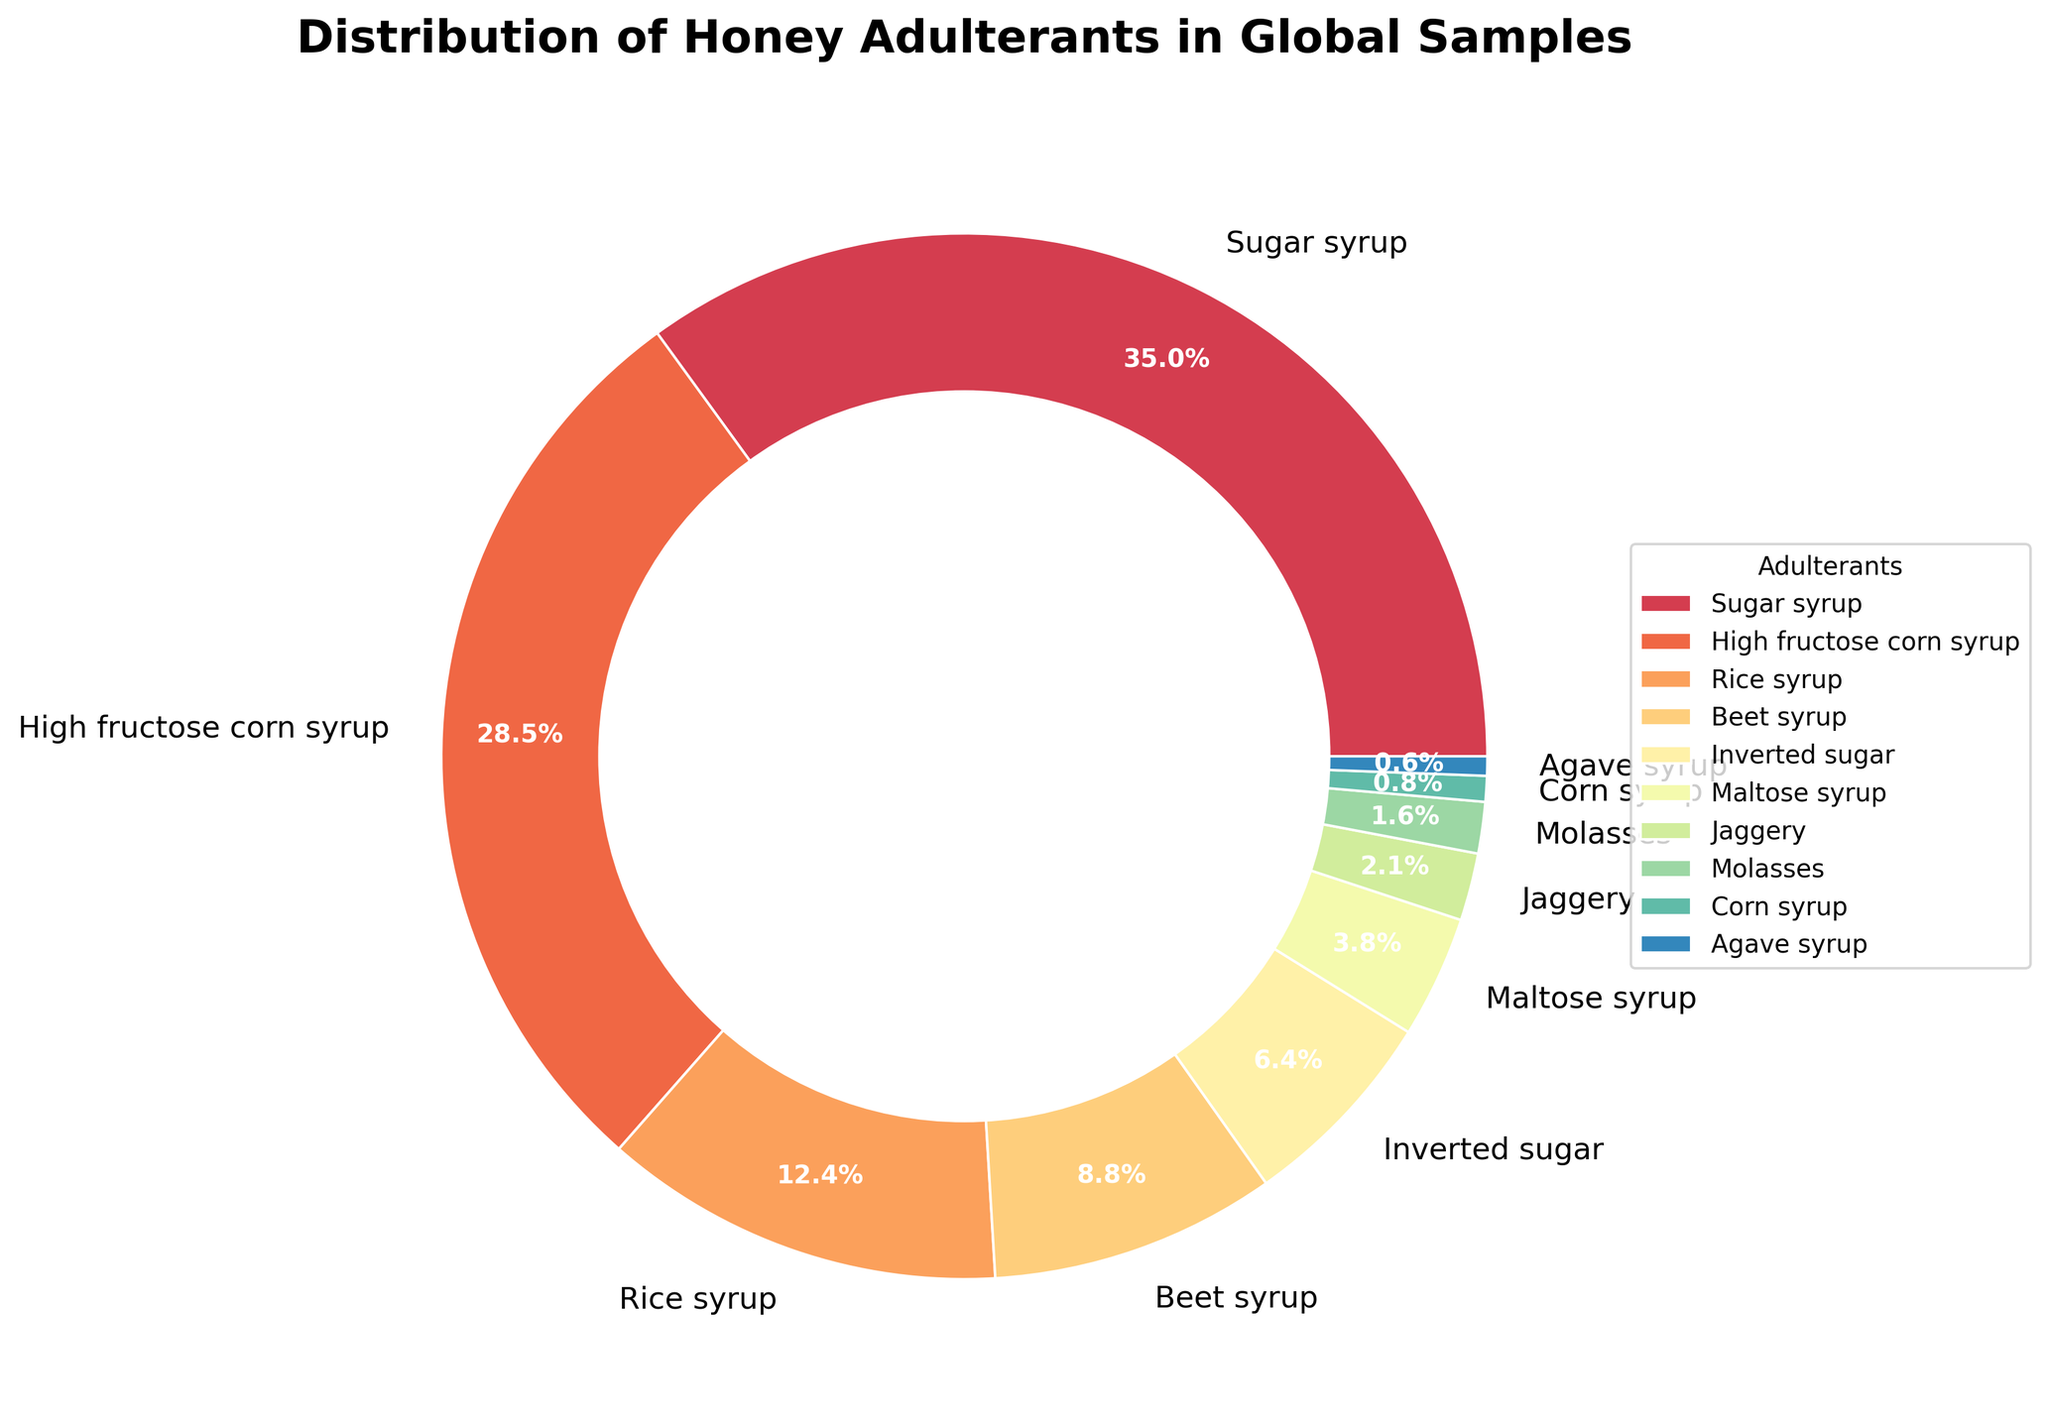Which adulterant is the most commonly detected in global honey samples? The largest segment in the pie chart belongs to "Sugar syrup", which shows it is the most commonly detected adulterant.
Answer: Sugar syrup Which two adulterants together make up more than 50% of the detected adulterants? By inspecting the pie chart, we see that "Sugar syrup" (35.2%) and "High fructose corn syrup" (28.7%) together make up more than 50% of the detected adulterants. Summing their percentages confirms this: 35.2% + 28.7% = 63.9%.
Answer: Sugar syrup and High fructose corn syrup What is the least detected adulterant in global honey samples? The smallest segment in the pie chart represents "Agave syrup" at 0.6%.
Answer: Agave syrup Which adulterant has a similar detection percentage to beet syrup? The closest to beet syrup's 8.9% is "Inverted sugar" with 6.4%.
Answer: Inverted sugar What is the combined percentage of the three least detected adulterants? The three least detected adulterants are Molasses (1.6%), Corn syrup (0.8%), and Agave syrup (0.6%). Adding them up: 1.6% + 0.8% + 0.6% = 3.0%.
Answer: 3.0% Is rice syrup detected more frequently than beet syrup? Rice syrup has a detection rate of 12.5%, while beet syrup has a detection rate of 8.9%, making rice syrup detected more frequently.
Answer: Yes What is the visual indication of the two most frequently detected adulterants? Visually, the largest and the second largest segments in the pie chart correspond to "Sugar syrup" and "High fructose corn syrup" respectively, suggesting these two are the most frequently detected adulterants.
Answer: Largest and second largest segments How much more frequently is the most detected adulterant found compared to the least detected one? "Sugar syrup" is detected at a rate of 35.2%, and "Agave syrup" at 0.6%. The difference is 35.2% - 0.6% = 34.6%.
Answer: 34.6% What's the cumulative percentage of adulterants detected at less than 10% each? Adulterants below 10% detection are Beet syrup (8.9%), Inverted sugar (6.4%), Maltose syrup (3.8%), Jaggery (2.1%), Molasses (1.6%), Corn syrup (0.8%), and Agave syrup (0.6%). Cumulative percentage: 8.9% + 6.4% + 3.8% + 2.1% + 1.6% + 0.8% + 0.6% = 24.2%.
Answer: 24.2% 